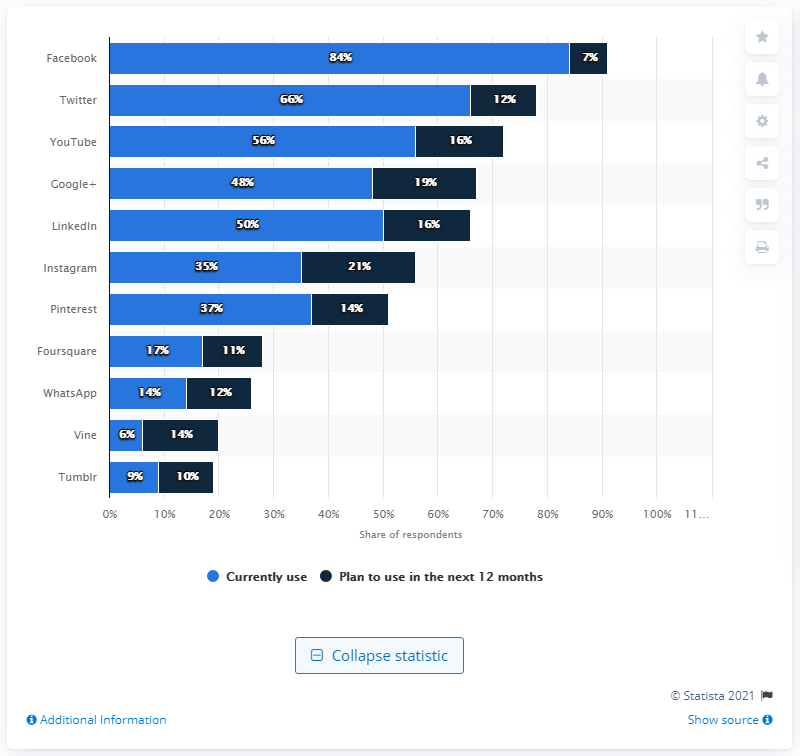Point out several critical features in this image. According to 56% of travel companies, they primarily use YouTube as a tool for their business. 